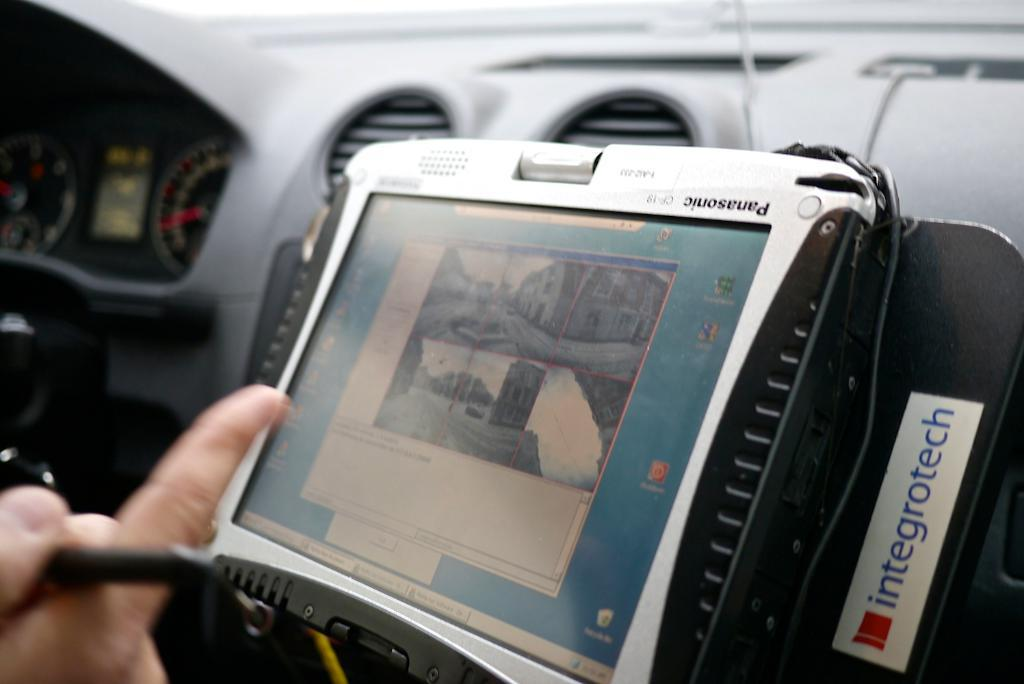What is the main subject of the image? The main subject of the image is a cockpit. Can you describe any specific features or objects within the cockpit? There is a gadget present in the middle of the image. Is there any indication of human presence in the image? Yes, there is a person's hand in the bottom left of the image. How many lizards can be seen crawling on the sidewalk in the image? There are no lizards or sidewalks present in the image; it features a cockpit with a gadget and a person's hand. 